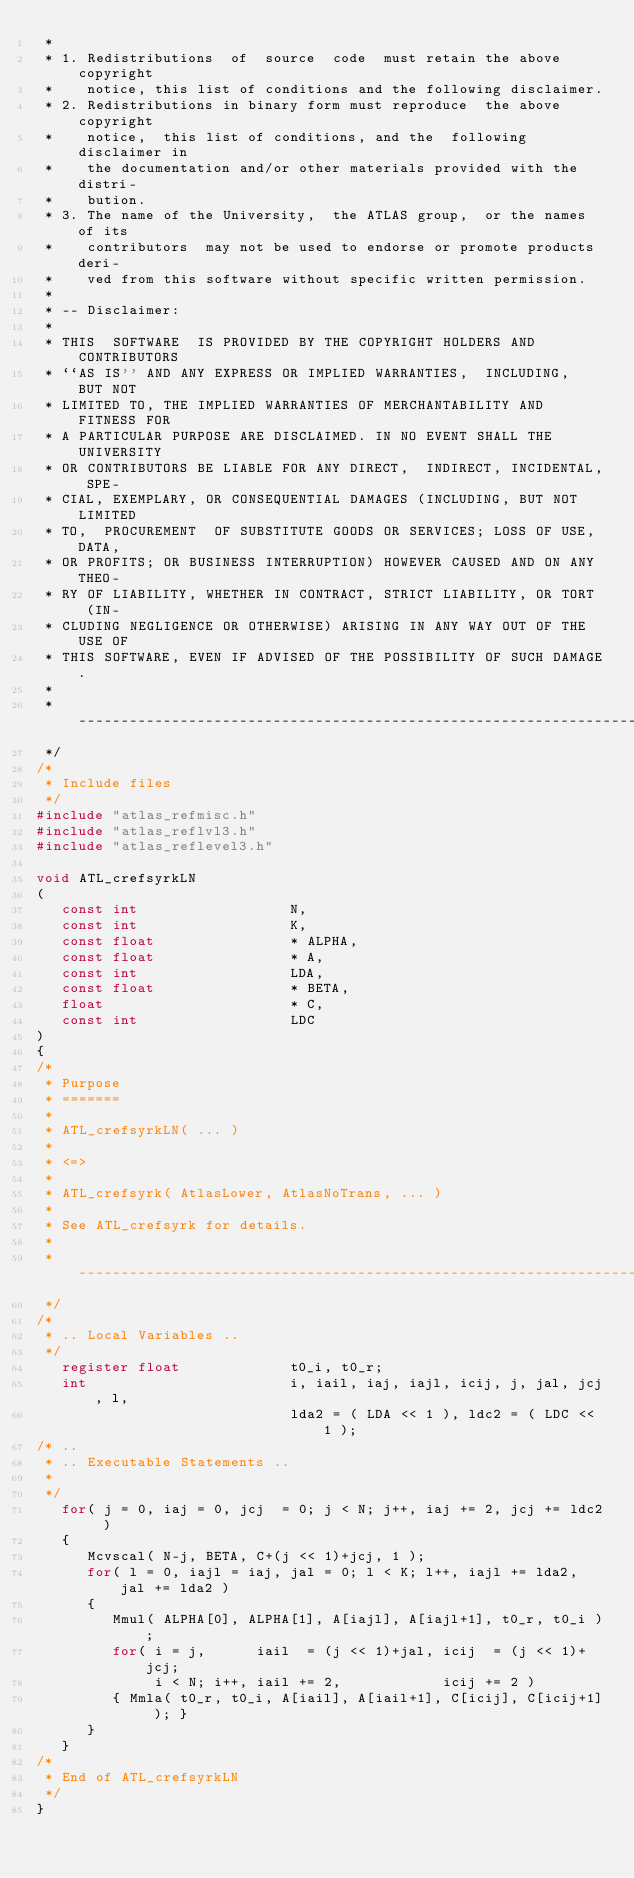Convert code to text. <code><loc_0><loc_0><loc_500><loc_500><_C_> *
 * 1. Redistributions  of  source  code  must retain the above copyright
 *    notice, this list of conditions and the following disclaimer.
 * 2. Redistributions in binary form must reproduce  the above copyright
 *    notice,  this list of conditions, and the  following disclaimer in
 *    the documentation and/or other materials provided with the distri-
 *    bution.
 * 3. The name of the University,  the ATLAS group,  or the names of its
 *    contributors  may not be used to endorse or promote products deri-
 *    ved from this software without specific written permission.
 *
 * -- Disclaimer:
 *
 * THIS  SOFTWARE  IS PROVIDED BY THE COPYRIGHT HOLDERS AND CONTRIBUTORS
 * ``AS IS'' AND ANY EXPRESS OR IMPLIED WARRANTIES,  INCLUDING,  BUT NOT
 * LIMITED TO, THE IMPLIED WARRANTIES OF MERCHANTABILITY AND FITNESS FOR
 * A PARTICULAR PURPOSE ARE DISCLAIMED. IN NO EVENT SHALL THE UNIVERSITY
 * OR CONTRIBUTORS BE LIABLE FOR ANY DIRECT,  INDIRECT, INCIDENTAL, SPE-
 * CIAL, EXEMPLARY, OR CONSEQUENTIAL DAMAGES (INCLUDING, BUT NOT LIMITED
 * TO,  PROCUREMENT  OF SUBSTITUTE GOODS OR SERVICES; LOSS OF USE, DATA,
 * OR PROFITS; OR BUSINESS INTERRUPTION) HOWEVER CAUSED AND ON ANY THEO-
 * RY OF LIABILITY, WHETHER IN CONTRACT, STRICT LIABILITY, OR TORT  (IN-
 * CLUDING NEGLIGENCE OR OTHERWISE) ARISING IN ANY WAY OUT OF THE USE OF
 * THIS SOFTWARE, EVEN IF ADVISED OF THE POSSIBILITY OF SUCH DAMAGE.
 *
 * ---------------------------------------------------------------------
 */
/*
 * Include files
 */
#include "atlas_refmisc.h"
#include "atlas_reflvl3.h"
#include "atlas_reflevel3.h"

void ATL_crefsyrkLN
(
   const int                  N,
   const int                  K,
   const float                * ALPHA,
   const float                * A,
   const int                  LDA,
   const float                * BETA,
   float                      * C,
   const int                  LDC
)
{
/*
 * Purpose
 * =======
 *
 * ATL_crefsyrkLN( ... )
 *
 * <=>
 *
 * ATL_crefsyrk( AtlasLower, AtlasNoTrans, ... )
 *
 * See ATL_crefsyrk for details.
 *
 * ---------------------------------------------------------------------
 */
/*
 * .. Local Variables ..
 */
   register float             t0_i, t0_r;
   int                        i, iail, iaj, iajl, icij, j, jal, jcj, l,
                              lda2 = ( LDA << 1 ), ldc2 = ( LDC << 1 );
/* ..
 * .. Executable Statements ..
 *
 */
   for( j = 0, iaj = 0, jcj  = 0; j < N; j++, iaj += 2, jcj += ldc2 )
   {
      Mcvscal( N-j, BETA, C+(j << 1)+jcj, 1 );
      for( l = 0, iajl = iaj, jal = 0; l < K; l++, iajl += lda2, jal += lda2 )
      {
         Mmul( ALPHA[0], ALPHA[1], A[iajl], A[iajl+1], t0_r, t0_i );
         for( i = j,      iail  = (j << 1)+jal, icij  = (j << 1)+jcj;
              i < N; i++, iail += 2,            icij += 2 )
         { Mmla( t0_r, t0_i, A[iail], A[iail+1], C[icij], C[icij+1] ); }
      }
   }
/*
 * End of ATL_crefsyrkLN
 */
}
</code> 